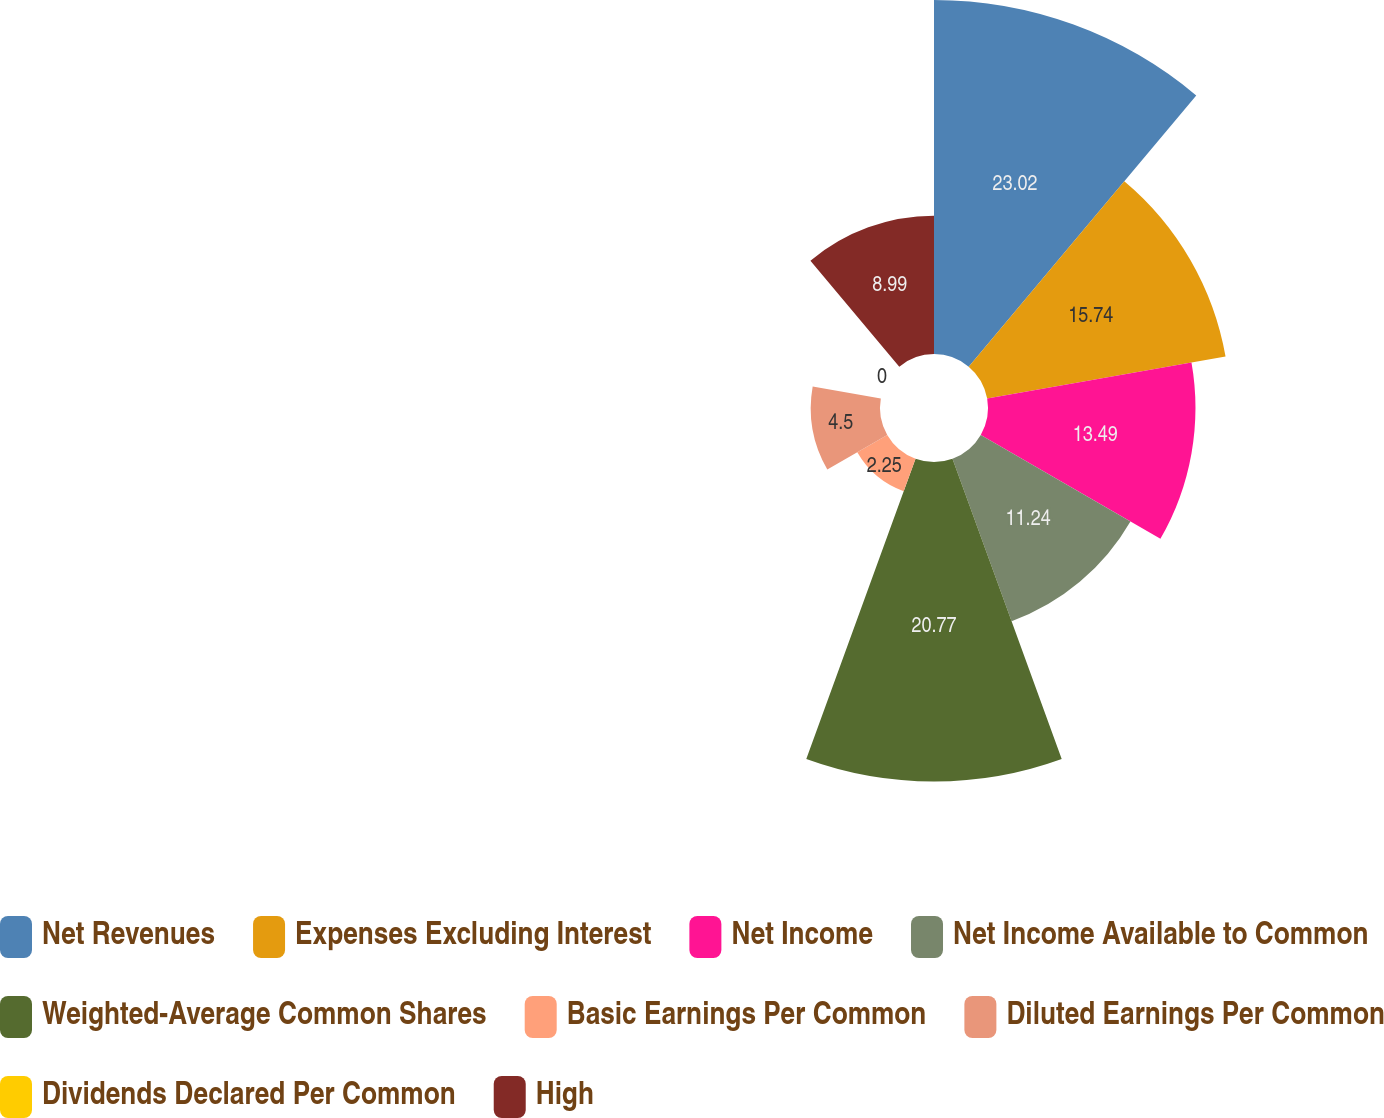Convert chart to OTSL. <chart><loc_0><loc_0><loc_500><loc_500><pie_chart><fcel>Net Revenues<fcel>Expenses Excluding Interest<fcel>Net Income<fcel>Net Income Available to Common<fcel>Weighted-Average Common Shares<fcel>Basic Earnings Per Common<fcel>Diluted Earnings Per Common<fcel>Dividends Declared Per Common<fcel>High<nl><fcel>23.02%<fcel>15.74%<fcel>13.49%<fcel>11.24%<fcel>20.77%<fcel>2.25%<fcel>4.5%<fcel>0.0%<fcel>8.99%<nl></chart> 